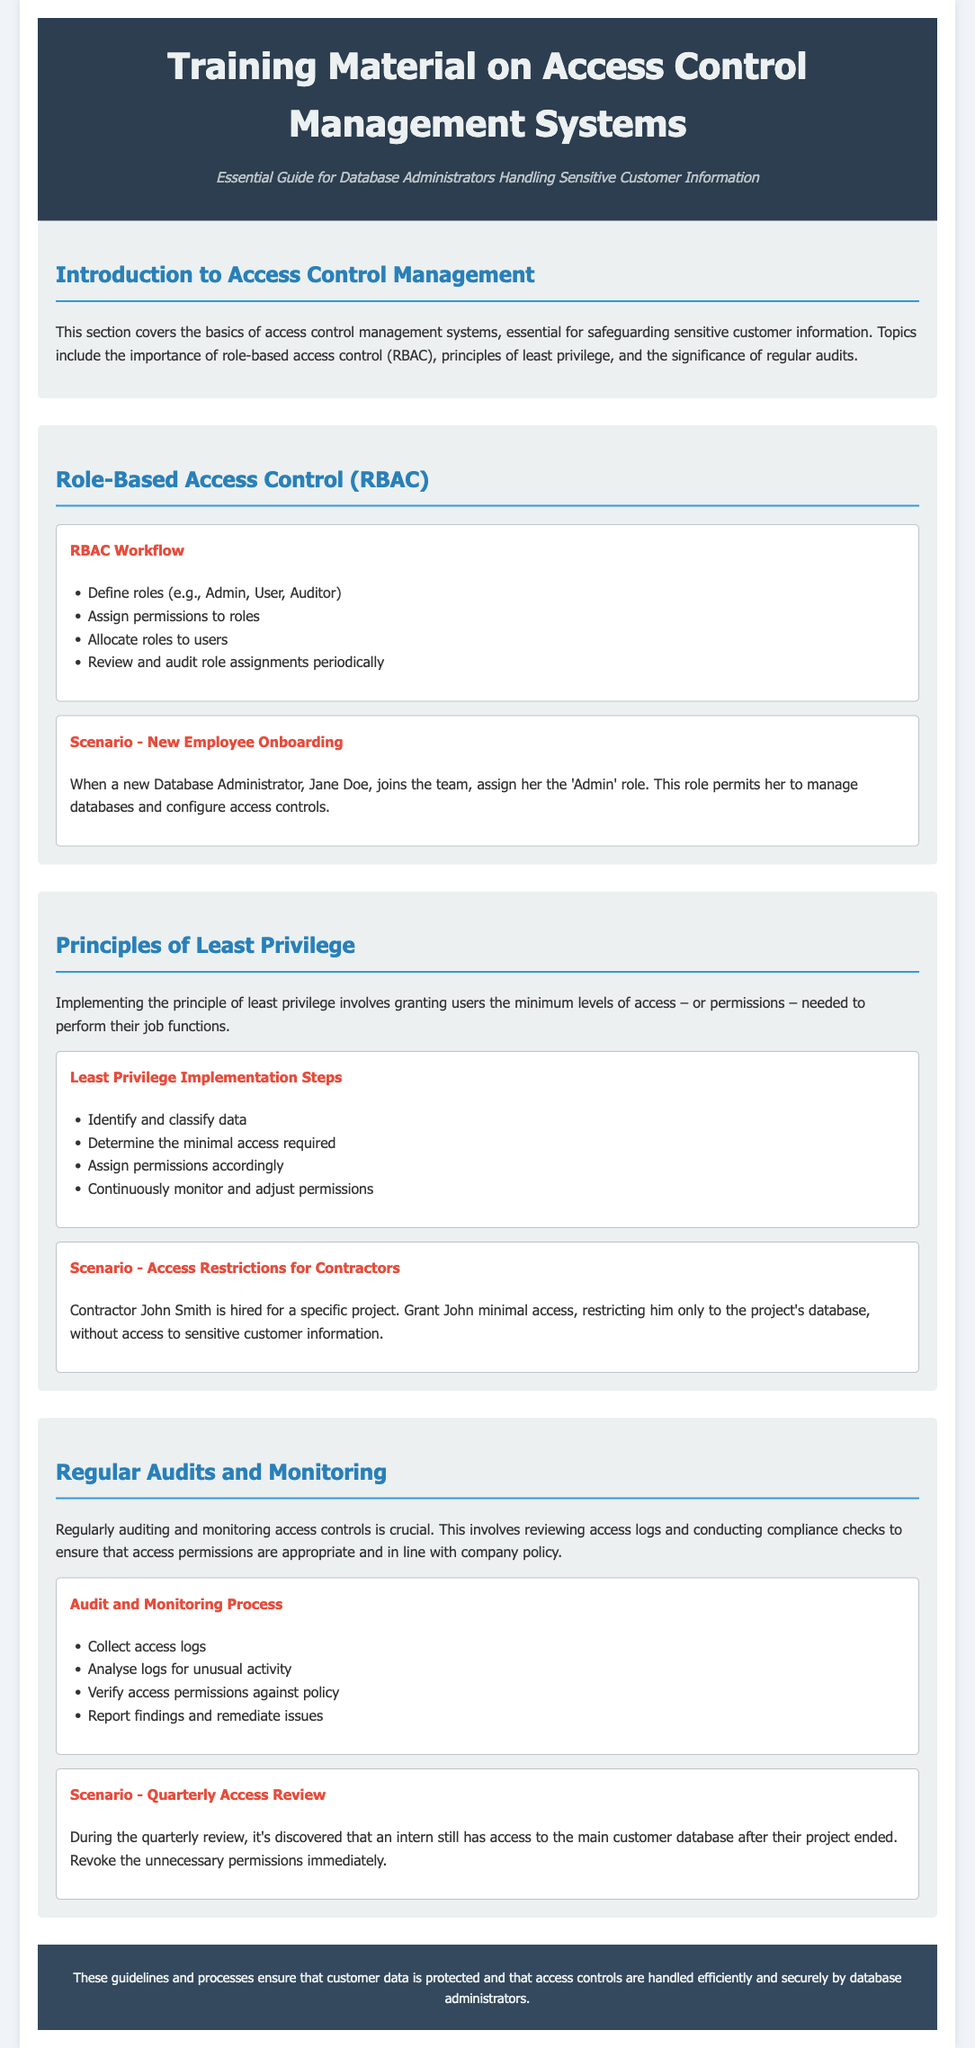What is the title of the training material? The title is prominently displayed at the top of the document, stating its purpose and focus.
Answer: Training Material on Access Control Management Systems What does RBAC stand for? The acronym is mentioned in the section dedicated to that topic, referring to a specific access control method.
Answer: Role-Based Access Control Who is the new Database Administrator mentioned in the scenario? The scenario provides details about a specific new hire to illustrate the RBAC section.
Answer: Jane Doe What is the first step in the Least Privilege Implementation Steps? The document outlines sequential steps for implementing least privilege, starting with identifying data.
Answer: Identify and classify data What type of access is granted to contractor John Smith? This scenario specifies the access level for a contractor to ensure security protocols are observed.
Answer: Minimal access How often are access reviews conducted according to the document? The document specifies the frequency of audits, which is key for maintaining access control security.
Answer: Quarterly What is the significance of regular audits mentioned in the document? The document explains the importance of this practice for security and compliance in managing access controls.
Answer: Crucial What color is used for the header background? The document describes the design elements, including colors, in the header section.
Answer: #2c3e50 What action was taken during the quarterly review? This scenario highlights a specific audit finding and the associated corrective action.
Answer: Revoke unnecessary permissions 